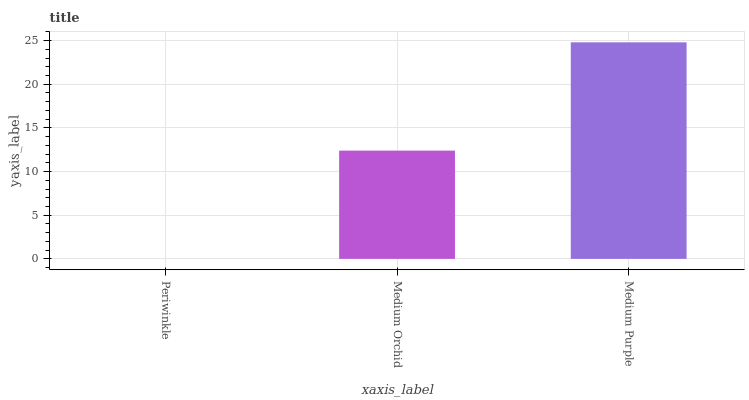Is Periwinkle the minimum?
Answer yes or no. Yes. Is Medium Purple the maximum?
Answer yes or no. Yes. Is Medium Orchid the minimum?
Answer yes or no. No. Is Medium Orchid the maximum?
Answer yes or no. No. Is Medium Orchid greater than Periwinkle?
Answer yes or no. Yes. Is Periwinkle less than Medium Orchid?
Answer yes or no. Yes. Is Periwinkle greater than Medium Orchid?
Answer yes or no. No. Is Medium Orchid less than Periwinkle?
Answer yes or no. No. Is Medium Orchid the high median?
Answer yes or no. Yes. Is Medium Orchid the low median?
Answer yes or no. Yes. Is Periwinkle the high median?
Answer yes or no. No. Is Medium Purple the low median?
Answer yes or no. No. 